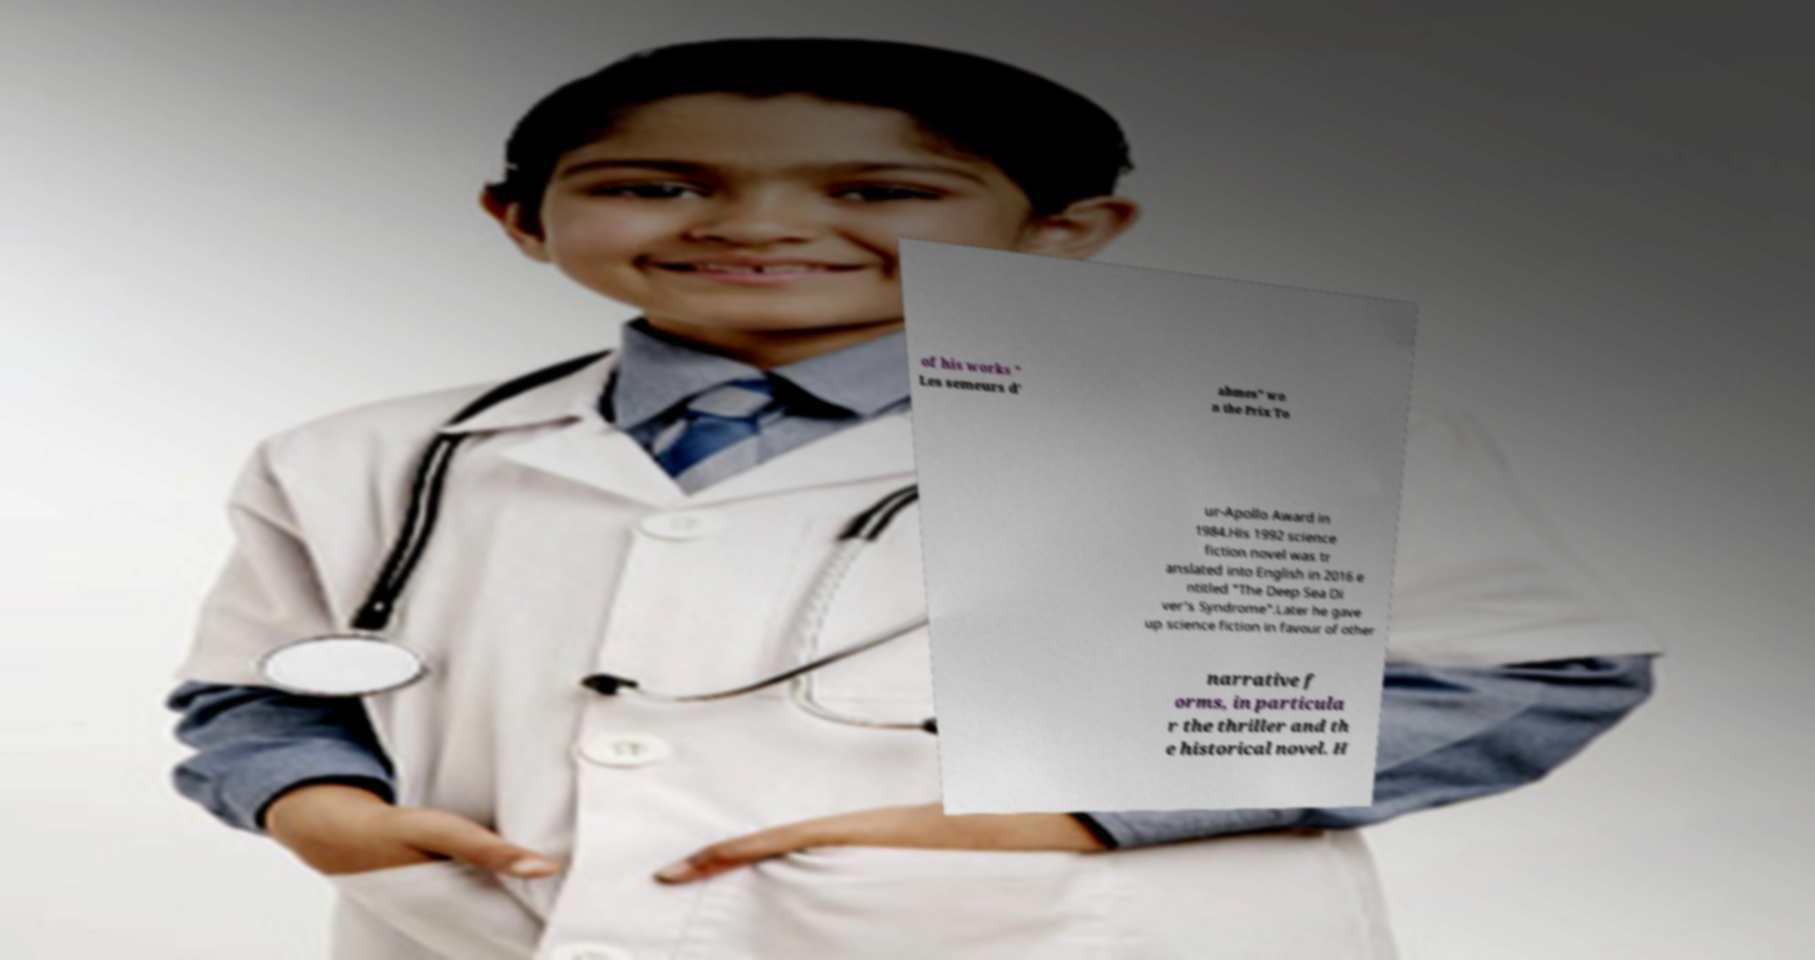What messages or text are displayed in this image? I need them in a readable, typed format. of his works " Les semeurs d' abmes" wo n the Prix To ur-Apollo Award in 1984.His 1992 science fiction novel was tr anslated into English in 2016 e ntitled "The Deep Sea Di ver's Syndrome".Later he gave up science fiction in favour of other narrative f orms, in particula r the thriller and th e historical novel. H 